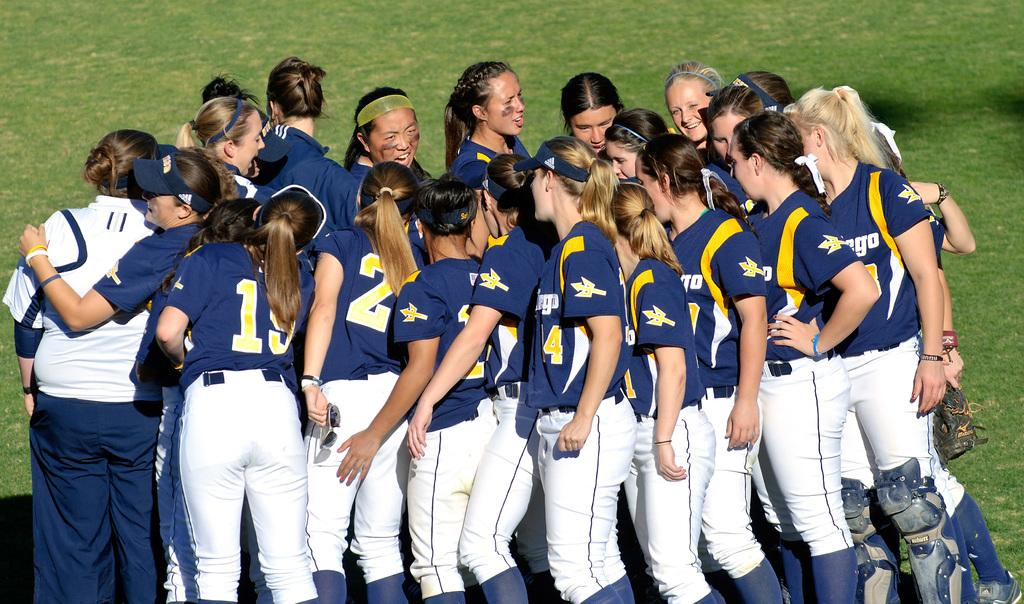<image>
Give a short and clear explanation of the subsequent image. A female sports team all huddled together, all except one has a blue jersey, one has white with the number 11 on the back. 